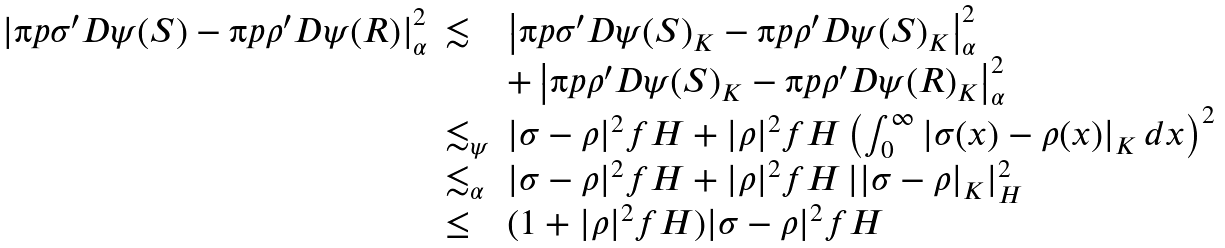Convert formula to latex. <formula><loc_0><loc_0><loc_500><loc_500>\begin{array} { r l l } \left | \i p { \sigma ^ { \prime } } { D \psi ( S ) } - \i p { \rho ^ { \prime } } { D \psi ( R ) } \right | ^ { 2 } _ { \alpha } & \lesssim & \left | \i p { \sigma ^ { \prime } } { D \psi ( S ) } _ { K } - \i p { \rho ^ { \prime } } { D \psi ( S ) } _ { K } \right | ^ { 2 } _ { \alpha } \\ & & + \left | \i p { \rho ^ { \prime } } { D \psi ( S ) } _ { K } - \i p { \rho ^ { \prime } } { D \psi ( R ) } _ { K } \right | ^ { 2 } _ { \alpha } \\ & \lesssim _ { \psi } & | \sigma - \rho | ^ { 2 } _ { \ } f H + | \rho | ^ { 2 } _ { \ } f H \left ( \int _ { 0 } ^ { \infty } | \sigma ( x ) - \rho ( x ) | _ { K } \, d x \right ) ^ { 2 } \\ & \lesssim _ { \alpha } & | \sigma - \rho | ^ { 2 } _ { \ } f H + | \rho | ^ { 2 } _ { \ } f H \, | | \sigma - \rho | _ { K } | _ { H } ^ { 2 } \\ & \leq & ( 1 + | \rho | ^ { 2 } _ { \ } f H ) | \sigma - \rho | ^ { 2 } _ { \ } f H \end{array}</formula> 